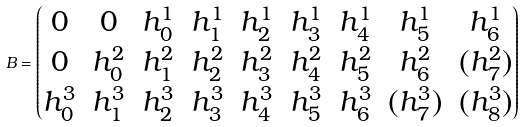<formula> <loc_0><loc_0><loc_500><loc_500>B = \begin{pmatrix} 0 & 0 & h ^ { 1 } _ { 0 } & h ^ { 1 } _ { 1 } & h ^ { 1 } _ { 2 } & h ^ { 1 } _ { 3 } & h ^ { 1 } _ { 4 } & h ^ { 1 } _ { 5 } & h ^ { 1 } _ { 6 } \\ 0 & h ^ { 2 } _ { 0 } & h ^ { 2 } _ { 1 } & h ^ { 2 } _ { 2 } & h ^ { 2 } _ { 3 } & h ^ { 2 } _ { 4 } & h ^ { 2 } _ { 5 } & h ^ { 2 } _ { 6 } & ( h ^ { 2 } _ { 7 } ) \\ h ^ { 3 } _ { 0 } & h ^ { 3 } _ { 1 } & h ^ { 3 } _ { 2 } & h ^ { 3 } _ { 3 } & h ^ { 3 } _ { 4 } & h ^ { 3 } _ { 5 } & h ^ { 3 } _ { 6 } & ( h ^ { 3 } _ { 7 } ) & ( h ^ { 3 } _ { 8 } ) \end{pmatrix}</formula> 